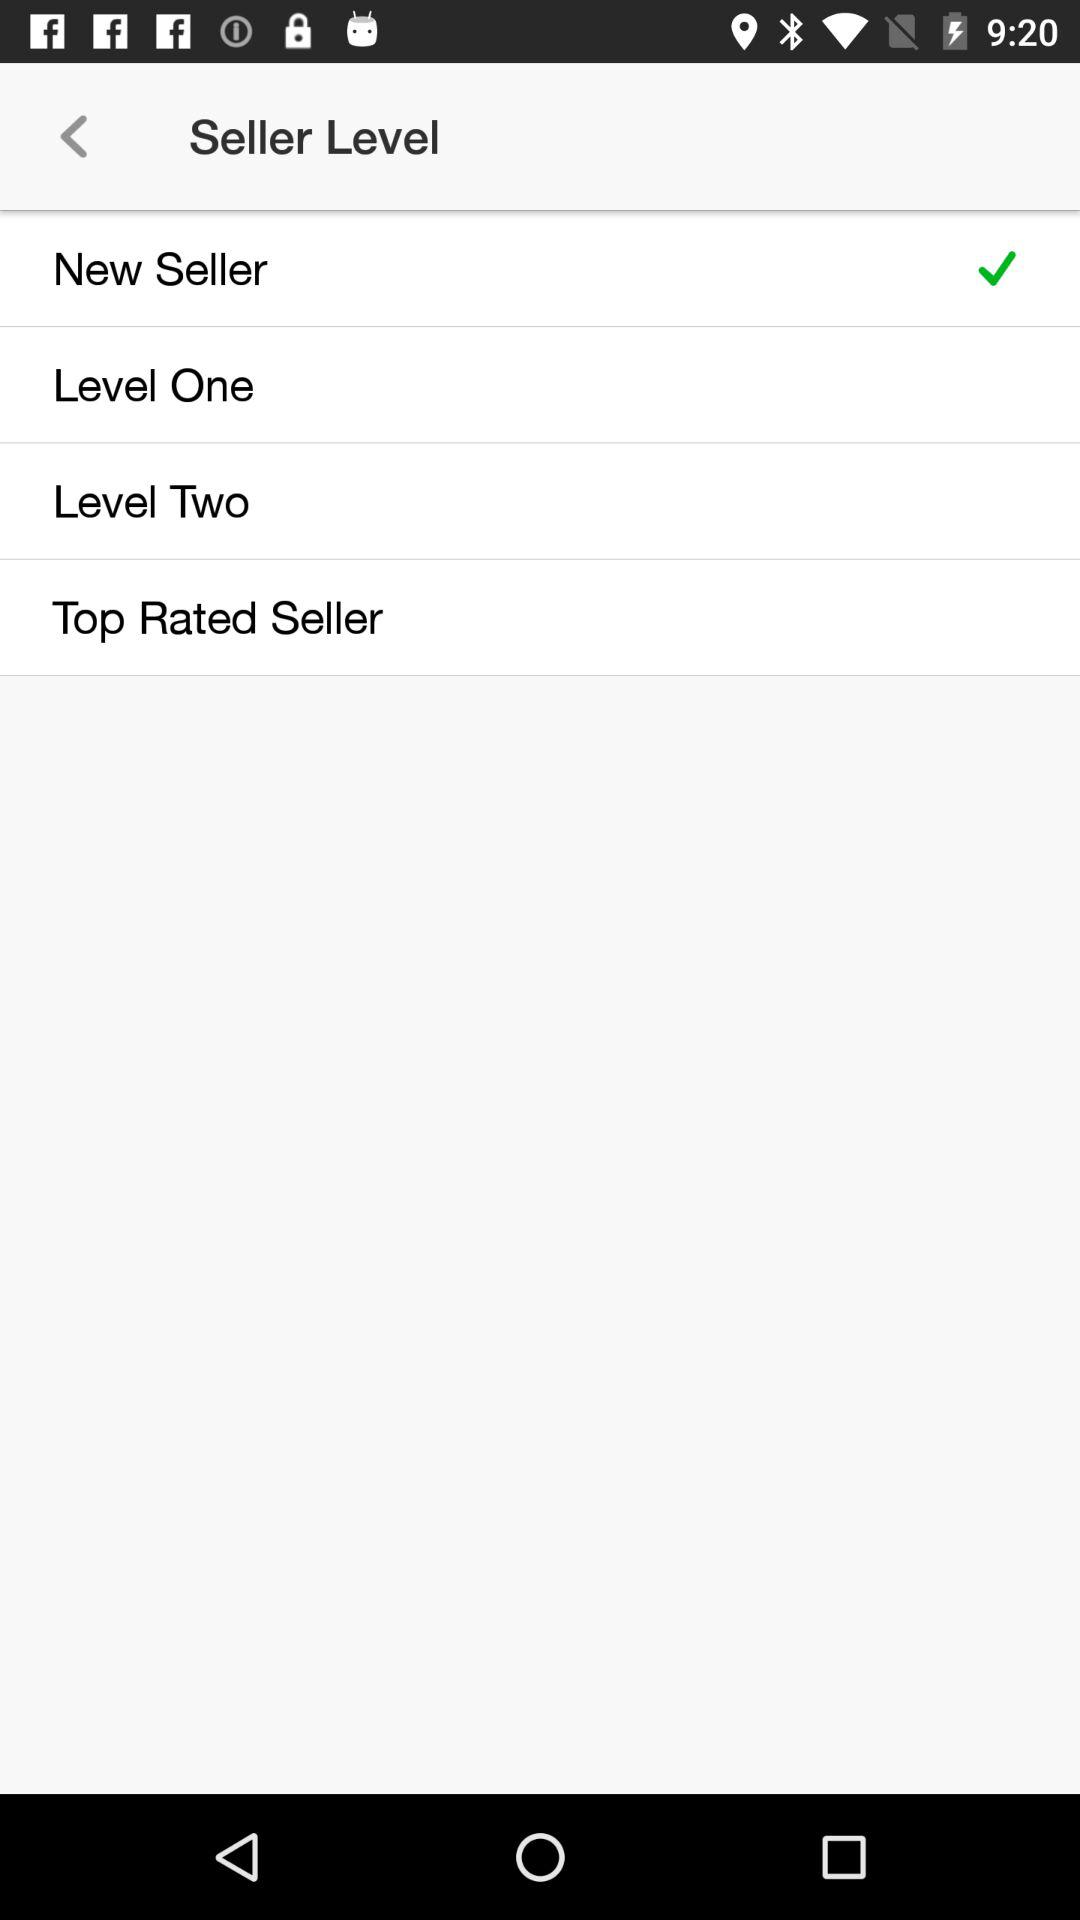What is the selected seller level? The selected seller level is "New Seller". 